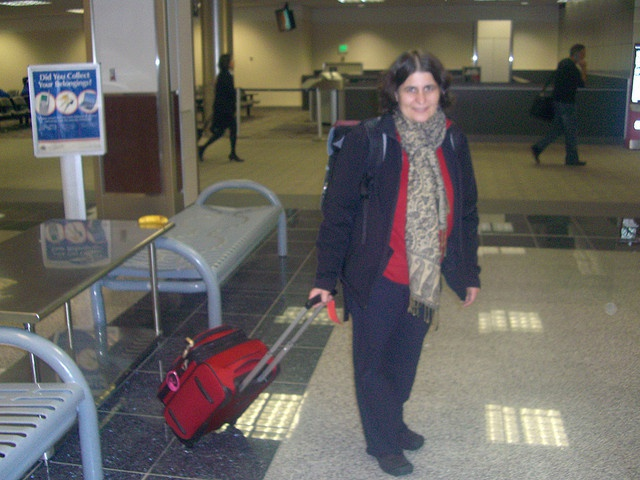Describe the objects in this image and their specific colors. I can see people in black, darkgray, and gray tones, bench in black and gray tones, bench in black, darkgray, and gray tones, suitcase in black, maroon, brown, and gray tones, and people in black, darkgreen, and gray tones in this image. 